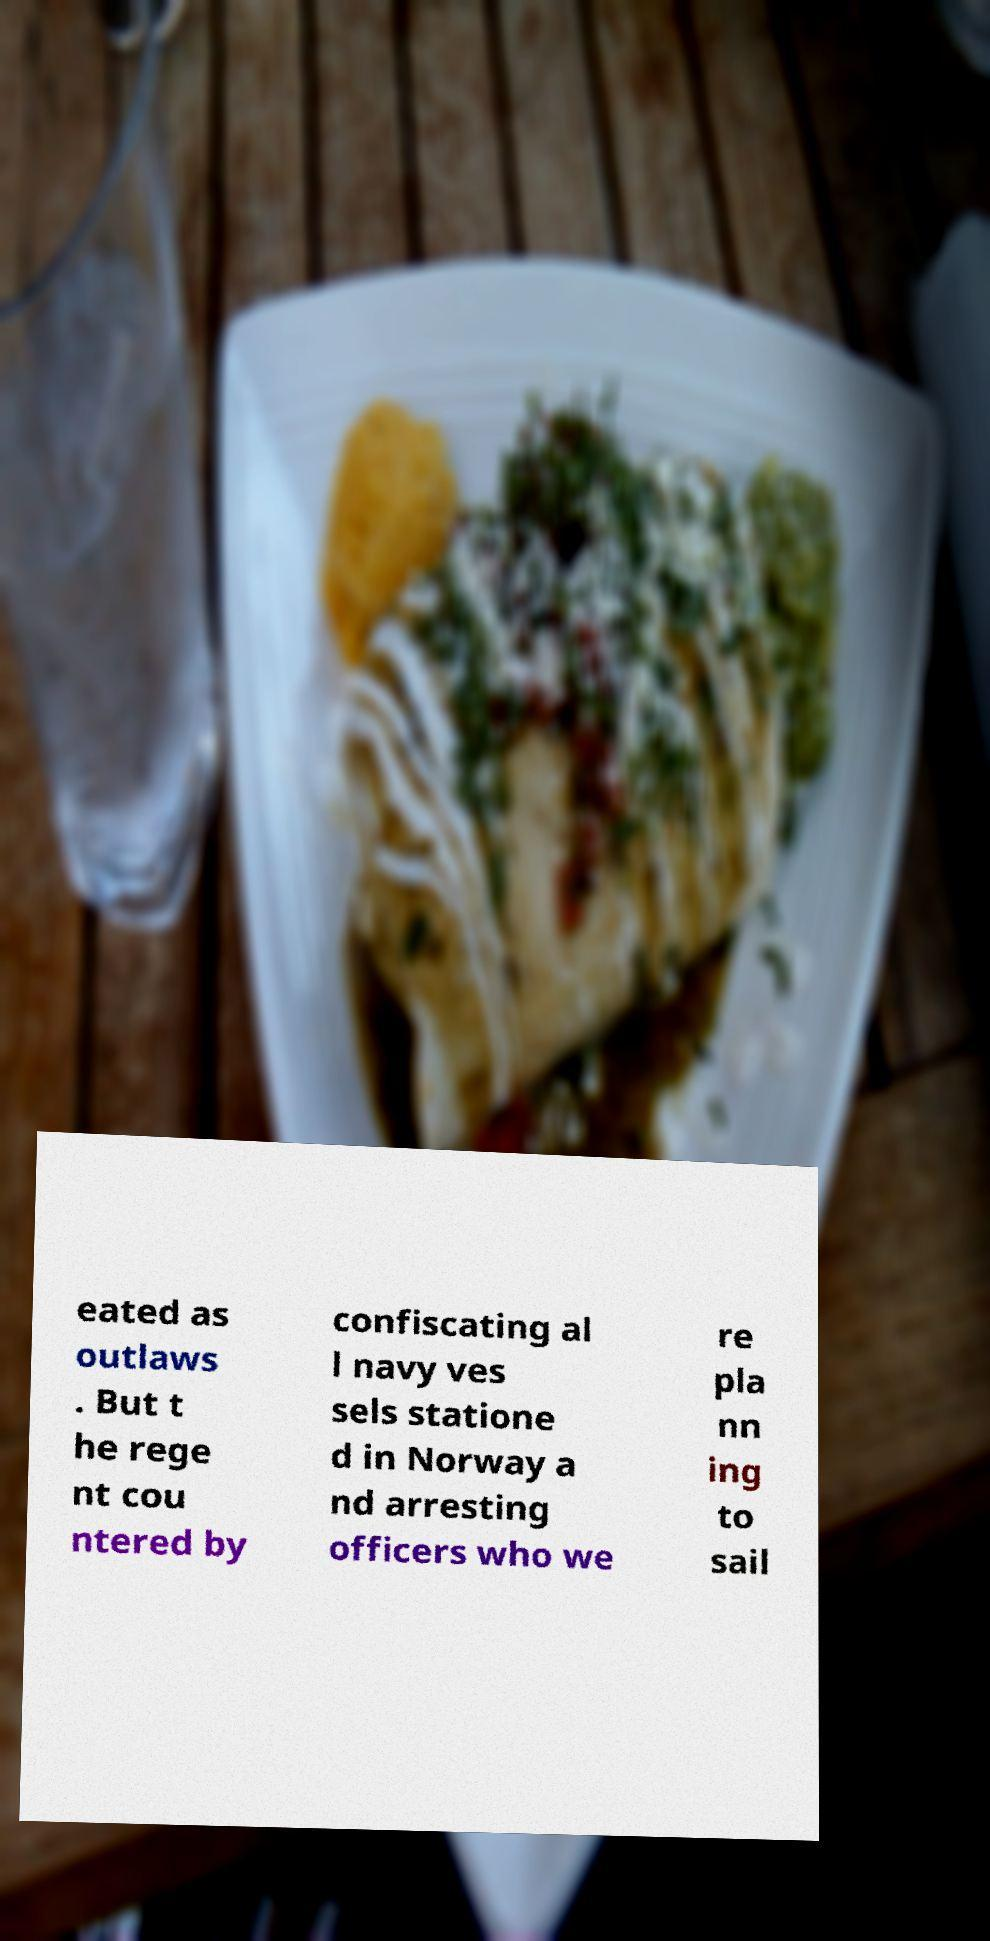Please identify and transcribe the text found in this image. eated as outlaws . But t he rege nt cou ntered by confiscating al l navy ves sels statione d in Norway a nd arresting officers who we re pla nn ing to sail 